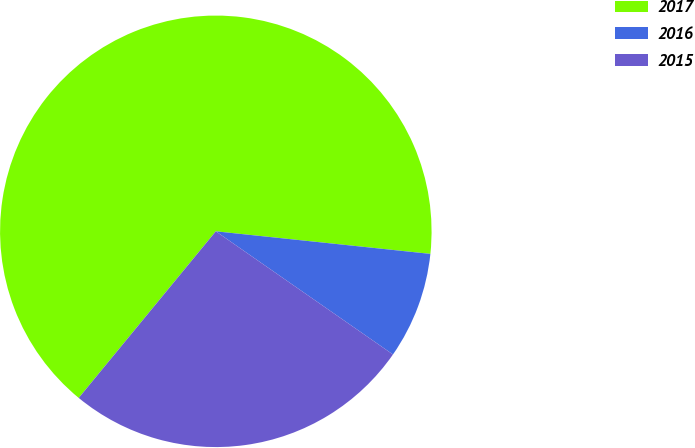Convert chart to OTSL. <chart><loc_0><loc_0><loc_500><loc_500><pie_chart><fcel>2017<fcel>2016<fcel>2015<nl><fcel>65.71%<fcel>8.0%<fcel>26.29%<nl></chart> 